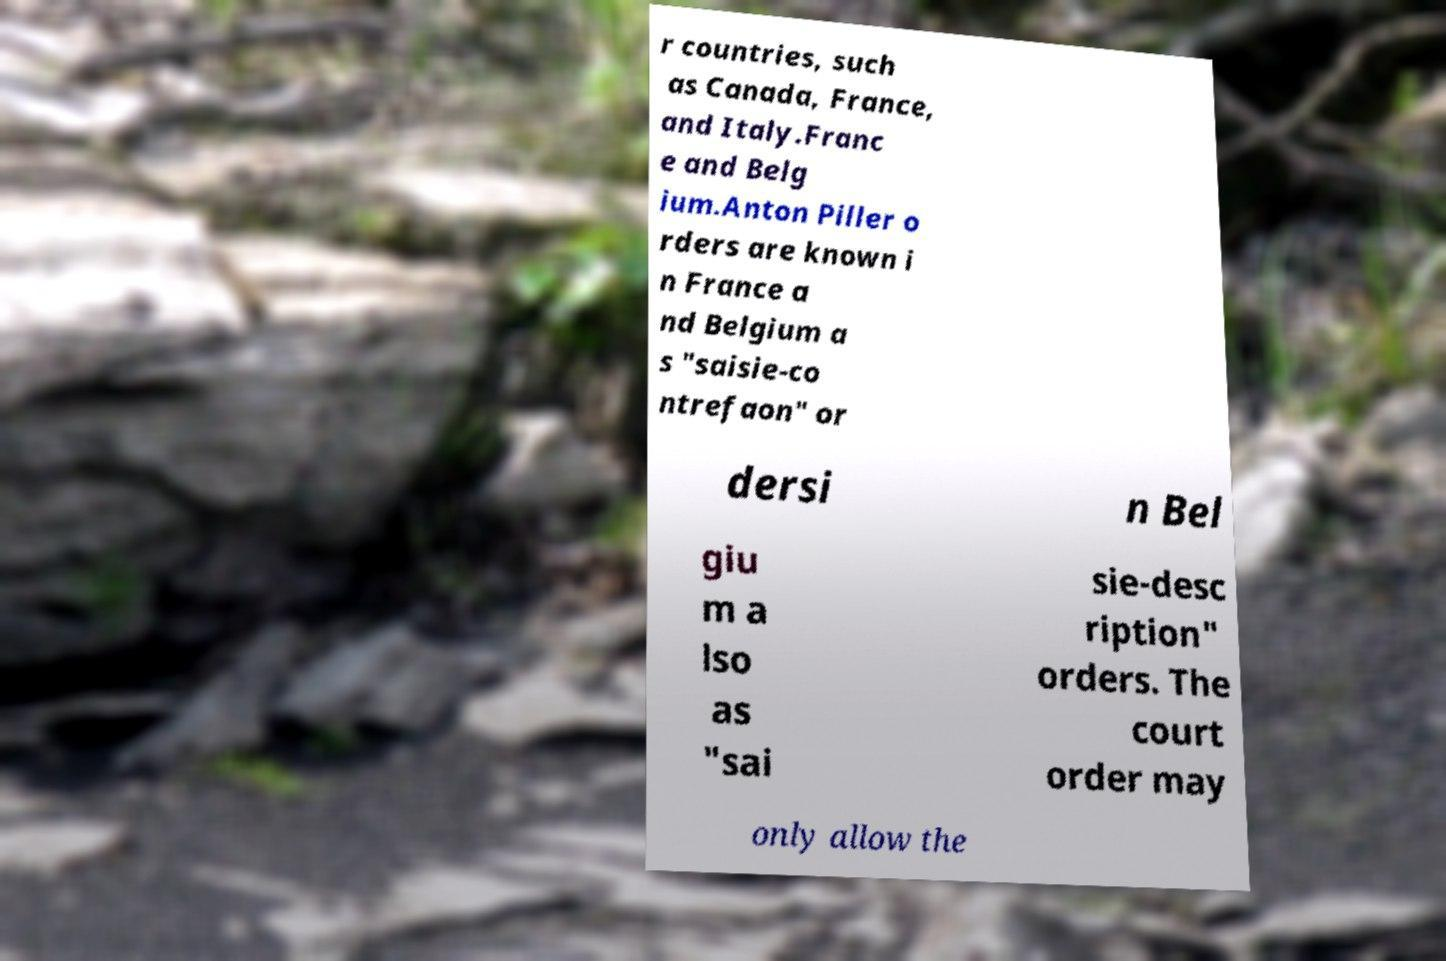Can you accurately transcribe the text from the provided image for me? r countries, such as Canada, France, and Italy.Franc e and Belg ium.Anton Piller o rders are known i n France a nd Belgium a s "saisie-co ntrefaon" or dersi n Bel giu m a lso as "sai sie-desc ription" orders. The court order may only allow the 